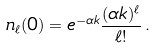Convert formula to latex. <formula><loc_0><loc_0><loc_500><loc_500>n _ { \ell } ( 0 ) = e ^ { - \alpha k } \frac { ( \alpha k ) ^ { \ell } } { \ell ! } \, .</formula> 